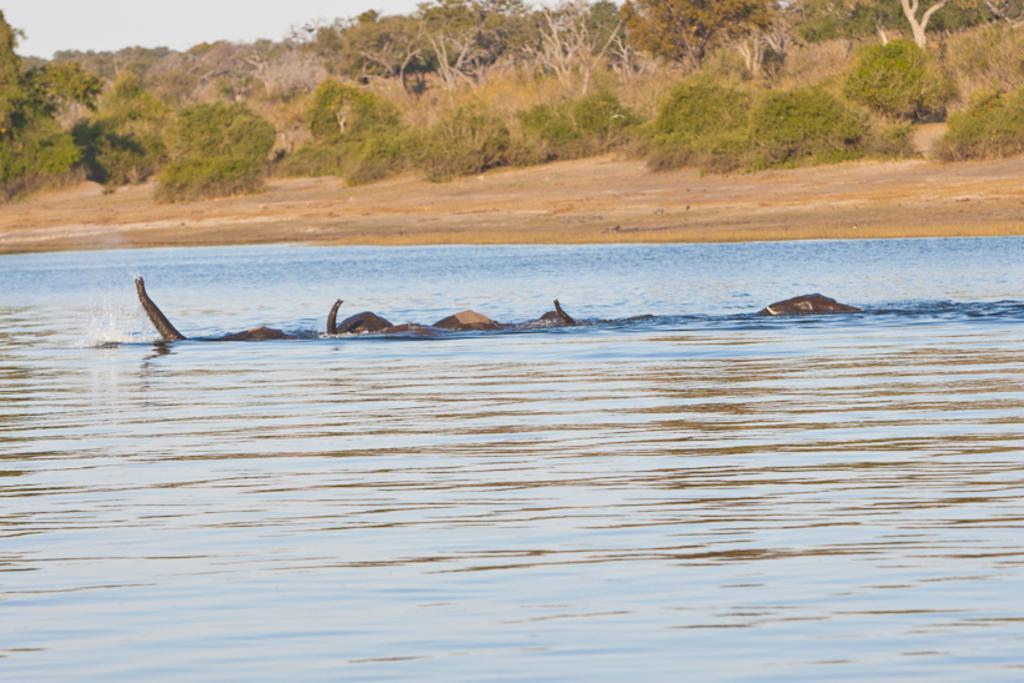Describe this image in one or two sentences. In this image we can see animals in the water. In the background there are trees, sky, bushes and ground. 